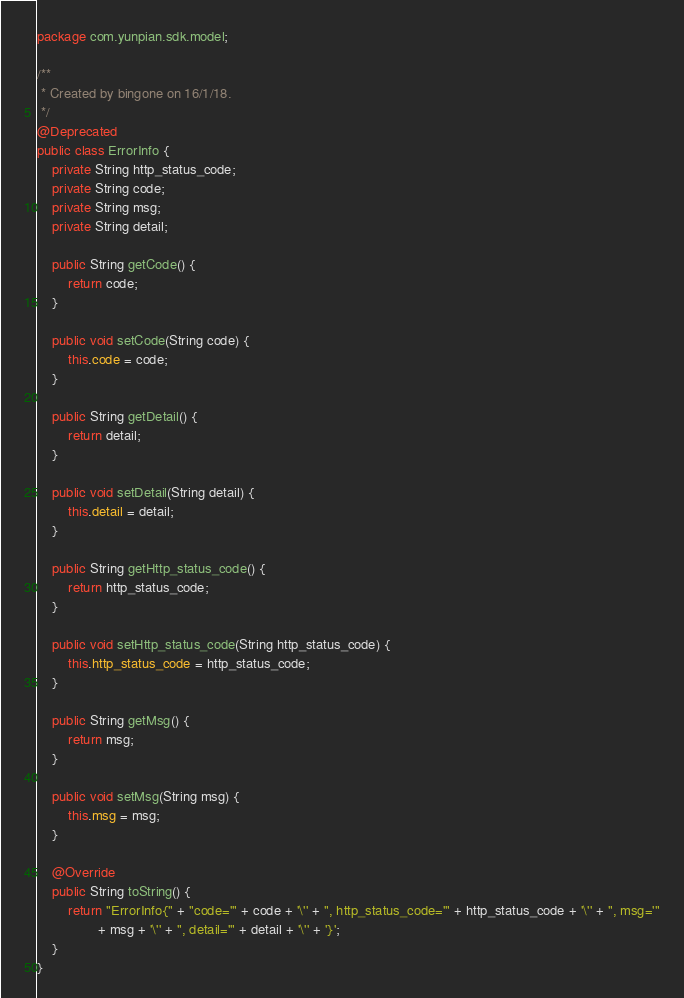<code> <loc_0><loc_0><loc_500><loc_500><_Java_>package com.yunpian.sdk.model;

/**
 * Created by bingone on 16/1/18.
 */
@Deprecated
public class ErrorInfo {
    private String http_status_code;
    private String code;
    private String msg;
    private String detail;

    public String getCode() {
        return code;
    }

    public void setCode(String code) {
        this.code = code;
    }

    public String getDetail() {
        return detail;
    }

    public void setDetail(String detail) {
        this.detail = detail;
    }

    public String getHttp_status_code() {
        return http_status_code;
    }

    public void setHttp_status_code(String http_status_code) {
        this.http_status_code = http_status_code;
    }

    public String getMsg() {
        return msg;
    }

    public void setMsg(String msg) {
        this.msg = msg;
    }

    @Override
    public String toString() {
        return "ErrorInfo{" + "code='" + code + '\'' + ", http_status_code='" + http_status_code + '\'' + ", msg='"
                + msg + '\'' + ", detail='" + detail + '\'' + '}';
    }
}
</code> 